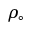<formula> <loc_0><loc_0><loc_500><loc_500>\rho _ { \circ }</formula> 